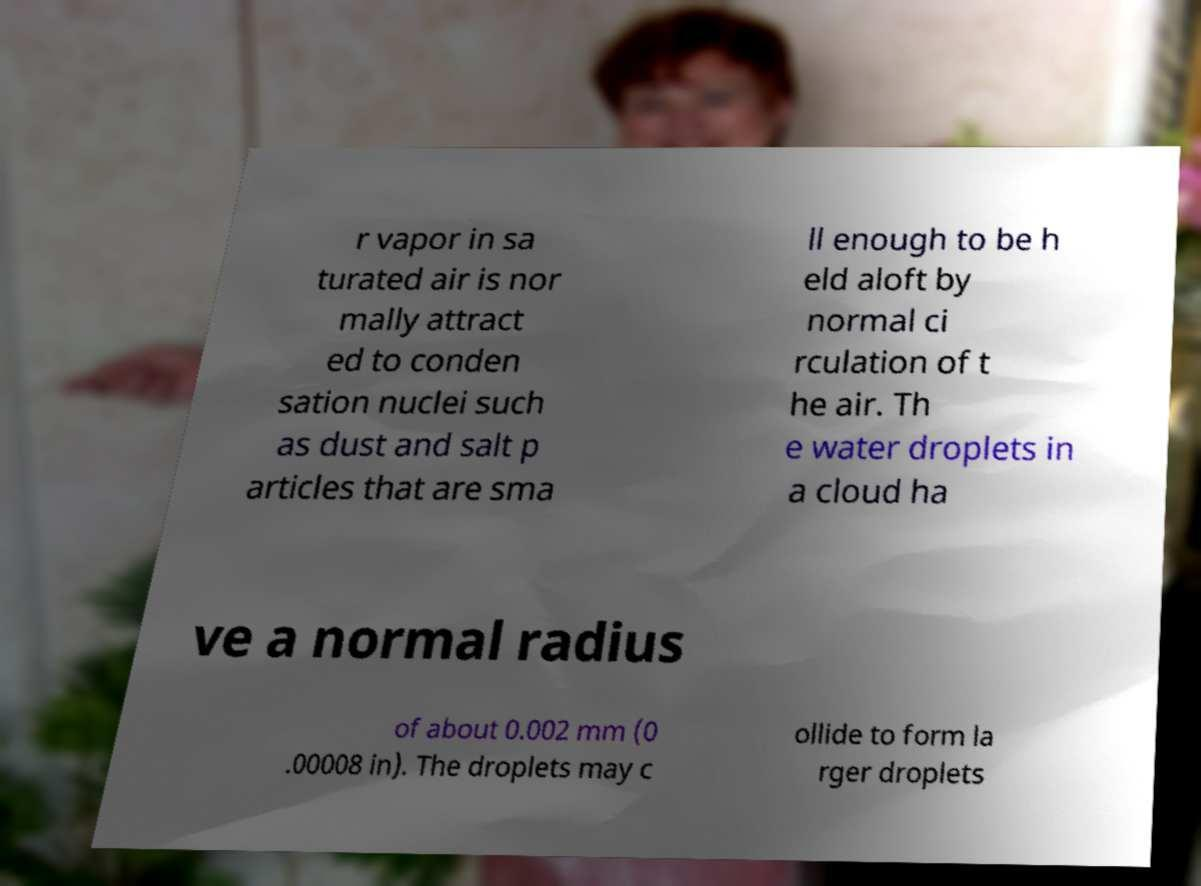There's text embedded in this image that I need extracted. Can you transcribe it verbatim? r vapor in sa turated air is nor mally attract ed to conden sation nuclei such as dust and salt p articles that are sma ll enough to be h eld aloft by normal ci rculation of t he air. Th e water droplets in a cloud ha ve a normal radius of about 0.002 mm (0 .00008 in). The droplets may c ollide to form la rger droplets 